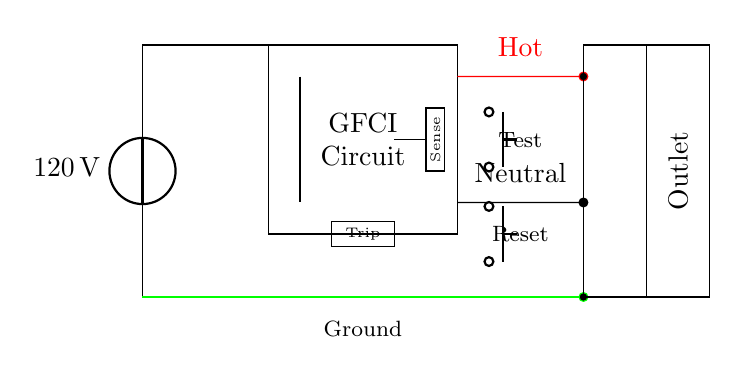What is the voltage of the circuit? The circuit shows a voltage source labeled as "120 V" at the beginning of the circuit diagram, establishing the potential difference for the circuit.
Answer: 120 V What component is represented in the rectangle labeled "GFCI"? The rectangular section marked "GFCI" indicates that this section is a Ground Fault Circuit Interrupter, which is designed to prevent electric shocks by disconnecting the circuit when it detects an imbalance of current.
Answer: Ground Fault Circuit Interrupter What color is the wire representing the ground connection? In the circuit diagram, the wire representing the ground connection is shown as green, which is a standard color code for grounding in electrical systems.
Answer: Green How many buttons are present in the GFCI assembly? The diagram shows two push buttons, one labeled "Test" and the other "Reset," which are integral to the GFCI operation for testing and resetting the device after a trip.
Answer: Two What is the purpose of the sense circuit in the diagram? The sense circuit, represented in the diagram as a small rectangle with the label "Sense," is responsible for monitoring the current flow to detect any discrepancies and trigger the trip mechanism of the GFCI.
Answer: Monitor current flow What happens when the "Test" button is pressed? Pressing the "Test" button simulates a ground fault, which causes the GFCI to trip, cutting off the current to prevent shock, thereby ensuring safety in wet areas such as bathrooms and kitchens.
Answer: Trips the circuit What type of electrical protection does this circuit provide? This circuit is designed to provide ground fault protection, which is specifically aimed at preventing electric shocks that may result from moisture contact in areas like kitchens and bathrooms.
Answer: Ground fault protection 